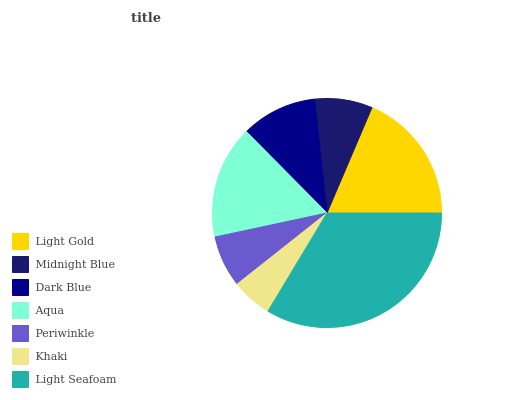Is Khaki the minimum?
Answer yes or no. Yes. Is Light Seafoam the maximum?
Answer yes or no. Yes. Is Midnight Blue the minimum?
Answer yes or no. No. Is Midnight Blue the maximum?
Answer yes or no. No. Is Light Gold greater than Midnight Blue?
Answer yes or no. Yes. Is Midnight Blue less than Light Gold?
Answer yes or no. Yes. Is Midnight Blue greater than Light Gold?
Answer yes or no. No. Is Light Gold less than Midnight Blue?
Answer yes or no. No. Is Dark Blue the high median?
Answer yes or no. Yes. Is Dark Blue the low median?
Answer yes or no. Yes. Is Periwinkle the high median?
Answer yes or no. No. Is Midnight Blue the low median?
Answer yes or no. No. 